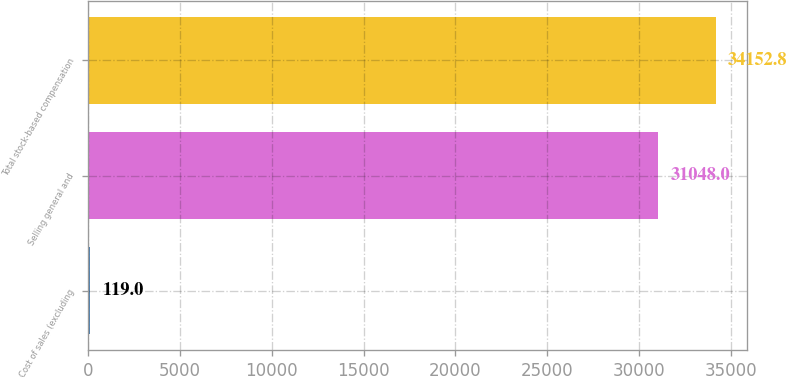Convert chart to OTSL. <chart><loc_0><loc_0><loc_500><loc_500><bar_chart><fcel>Cost of sales (excluding<fcel>Selling general and<fcel>Total stock-based compensation<nl><fcel>119<fcel>31048<fcel>34152.8<nl></chart> 